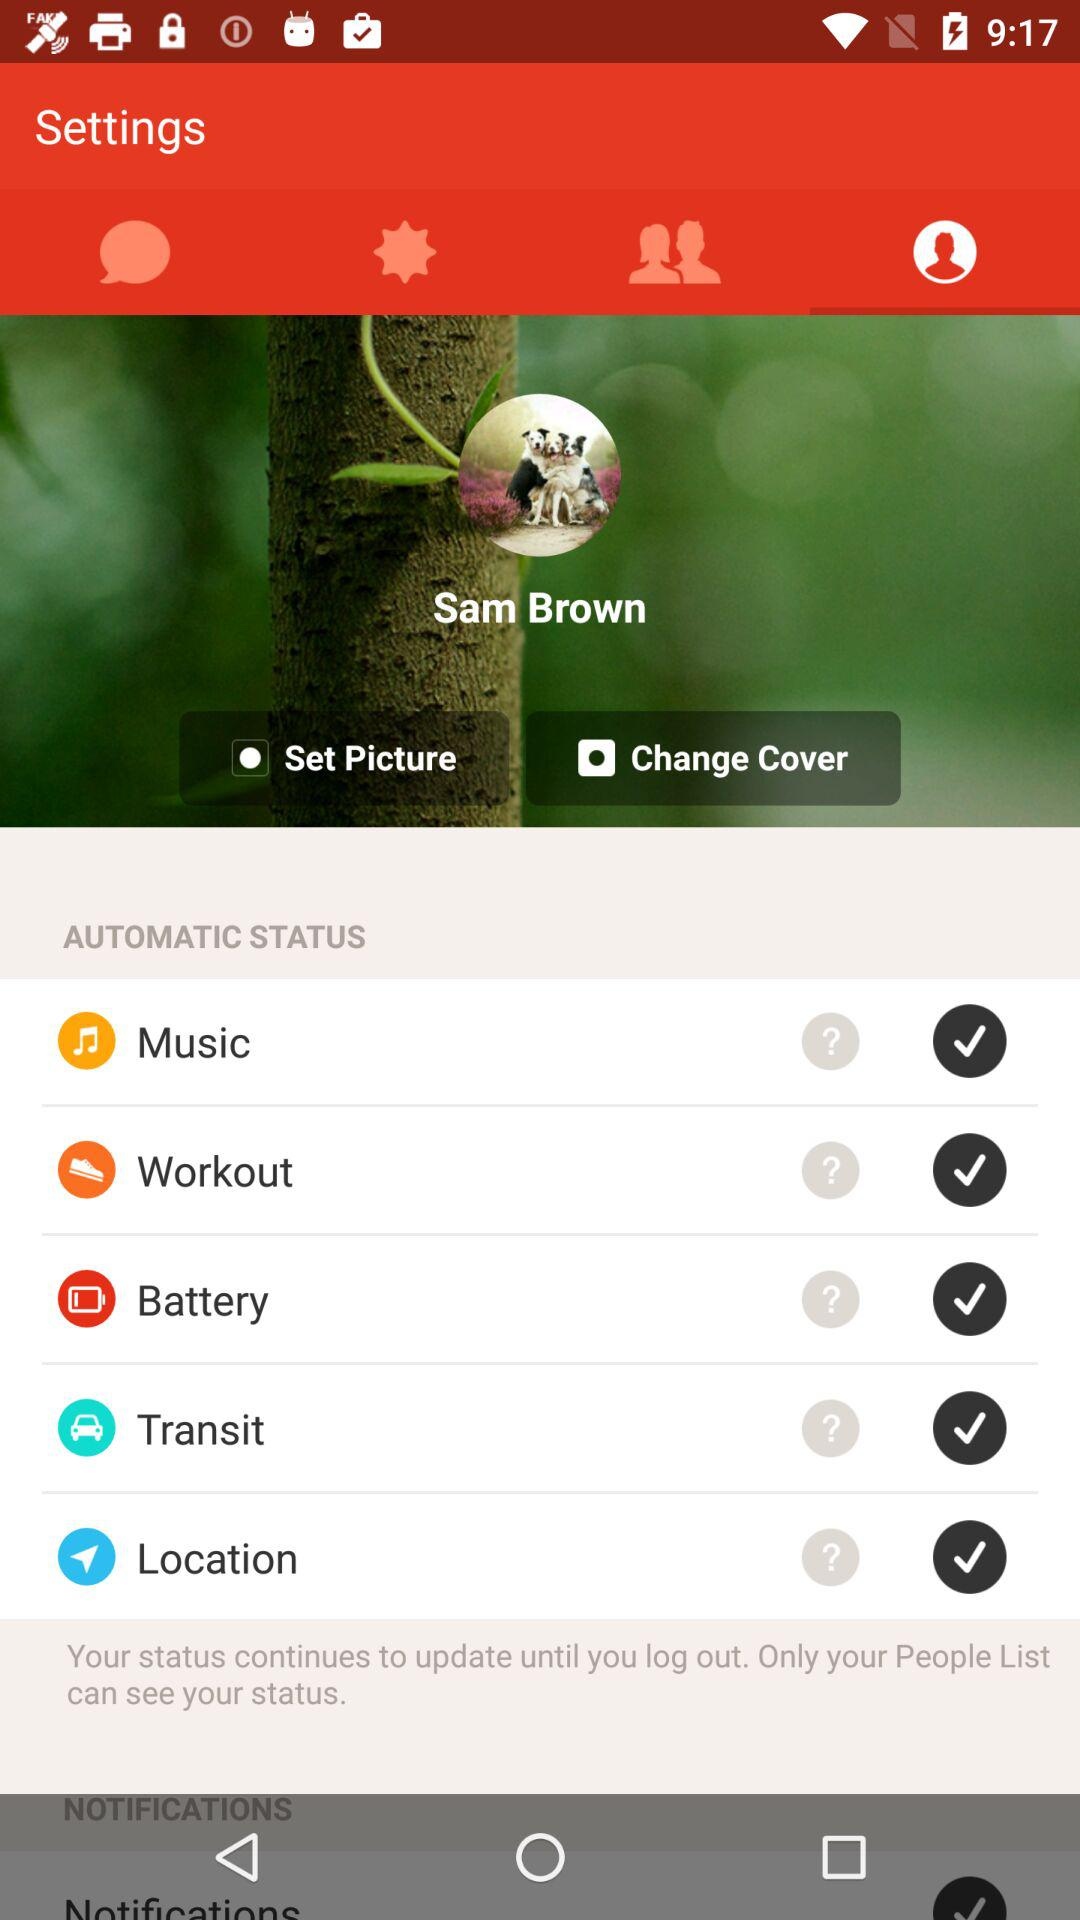What is the user name? The user name is Sam Brown. 